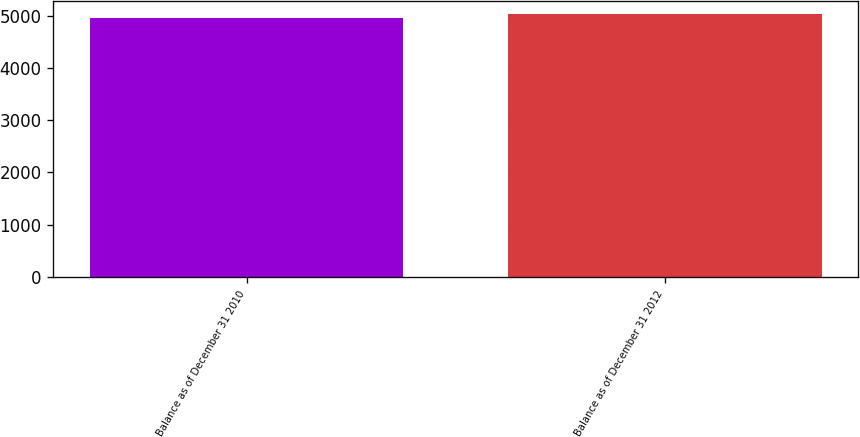Convert chart to OTSL. <chart><loc_0><loc_0><loc_500><loc_500><bar_chart><fcel>Balance as of December 31 2010<fcel>Balance as of December 31 2012<nl><fcel>4952<fcel>5028<nl></chart> 